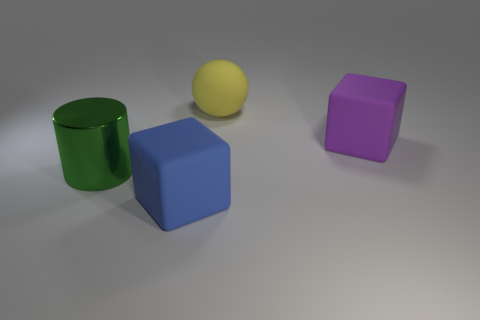Add 3 tiny gray rubber objects. How many objects exist? 7 Subtract all cylinders. How many objects are left? 3 Subtract all purple blocks. How many blocks are left? 1 Subtract 1 cylinders. How many cylinders are left? 0 Add 4 blocks. How many blocks exist? 6 Subtract 0 gray balls. How many objects are left? 4 Subtract all purple balls. Subtract all red cylinders. How many balls are left? 1 Subtract all purple metal spheres. Subtract all big rubber objects. How many objects are left? 1 Add 3 large objects. How many large objects are left? 7 